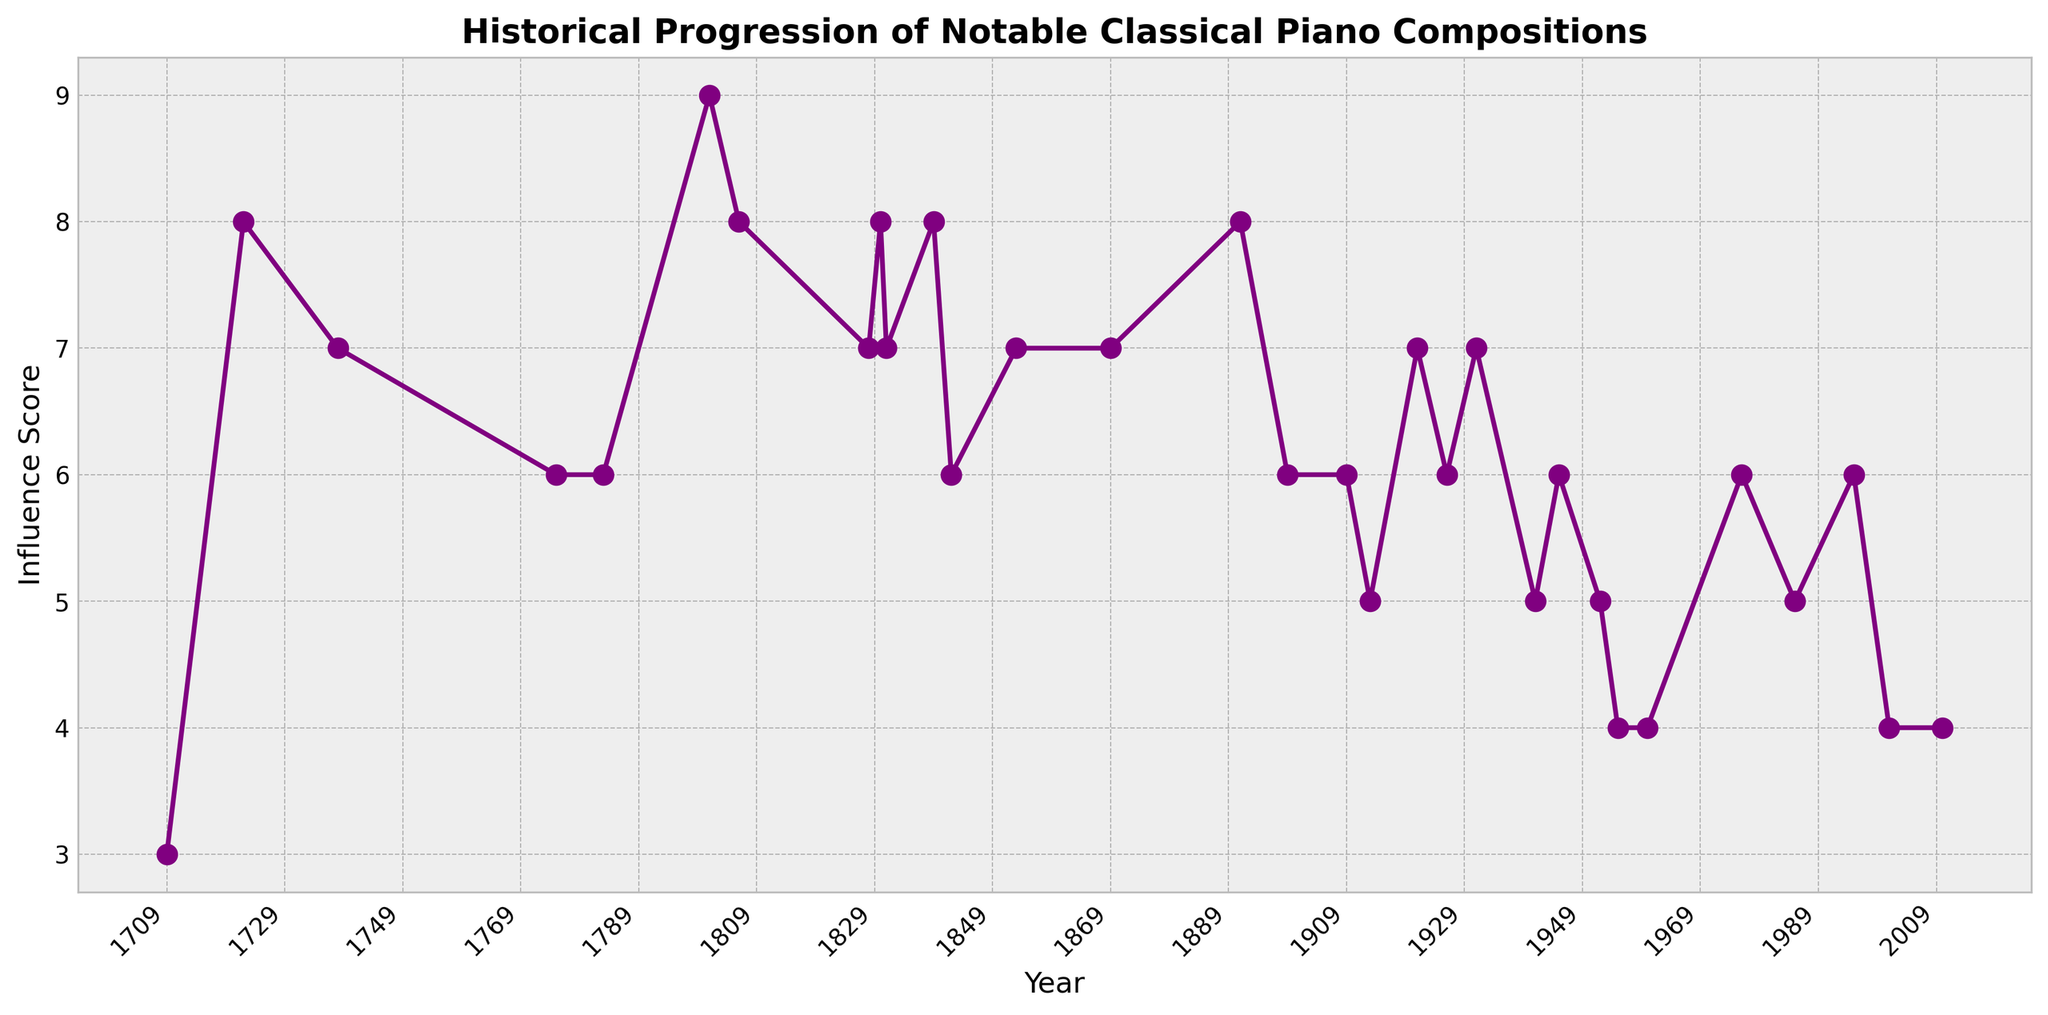What's the highest Influence Score observed on the chart and in which year did it occur? The highest Influence Score is represented by the tallest point on the chart. Observing the chart, the highest point is 9. This peak occurs in the year 1801 for 'Sonata No. 14 'Moonlight'' by Ludwig van Beethoven.
Answer: 9, 1801 How many compositions have an Influence Score of 8? Count the number of data points that align with the value of 8 on the y-axis. Looking at the chart, there are 6 compositions with an Influence Score of 8.
Answer: 6 Which decade had the highest average Influence Score? Calculate the average Influence Score for each decade. From visual inspection, the 1800s, particularly around 1801 and 1806, show high scores of 9 and 8, giving it an average of 8.5 for that period. This appears higher than other decades.
Answer: 1800s What is the range of Influence Scores displayed in the chart? Identify the minimum and maximum Influence Scores on the chart. The lowest value in the chart is 3 and the highest is 9. The range is the difference between these two values: 9 - 3 = 6.
Answer: 6 How does the Influence Score trend change from 1709 to 1952? Observe the overall upward or downward movements of the Influence Score from 1709 to 1952. Initially, the scores increase significantly, reaching peaks in the late 1800s. Afterward, there’s a general decline or stabilization around mid-range values towards 1952.
Answer: Rises initially, peaks, then declines/stabilizes In which year did the Influence Score first reach 7? Locate the first instance where a data point aligns with 7 on the y-axis upon moving from left to right on the chart. The Influence Score reaches 7 for the first time in the year 1738.
Answer: 1738 Compare the Influence Scores in the 1830s for Frédéric Chopin and Robert Schumann. Who had a higher influence? Identify the scores in the 1830s, specifically for works by these composers. Frédéric Chopin's "Mazurkas" (1831) and "Nocturnes" (1839) both have scores of 7 and 8, respectively. Robert Schumann's "Kinderszenen" (1842) has a score of 6. Chopin consistently had higher scores.
Answer: Frédéric Chopin What is the median Influence Score for the compositions before 1850? List out the scores before 1850: 3, 8, 7, 6, 6, 9, 8, 7, 8, 7, 6, 7, 8, 6, 7, 8. The median is the middle value when the data is ordered. Ordered Scores: 3, 6, 6, 6, 6, 7, 7, 7, 7, 8, 8, 8, 8, 8, 9. The median is 7.
Answer: 7 Which composer has the most compositions with an Influence Score of 7 and above? Review the chart for composers with multiple works scoring 7 or above. Johann Sebastian Bach (8, 7), Franz Liszt (8, 7), and Frédéric Chopin (8, 7). Bach and Liszt each have 2 compositions, making them the highest.
Answer: Johann Sebastian Bach and Franz Liszt 